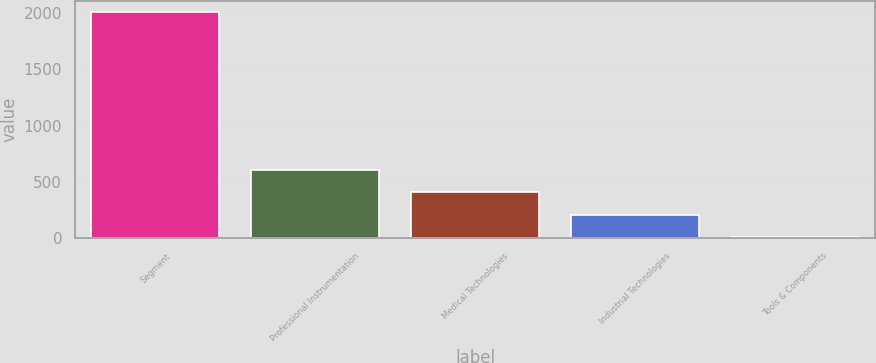Convert chart to OTSL. <chart><loc_0><loc_0><loc_500><loc_500><bar_chart><fcel>Segment<fcel>Professional Instrumentation<fcel>Medical Technologies<fcel>Industrial Technologies<fcel>Tools & Components<nl><fcel>2009<fcel>609<fcel>409<fcel>209<fcel>9<nl></chart> 